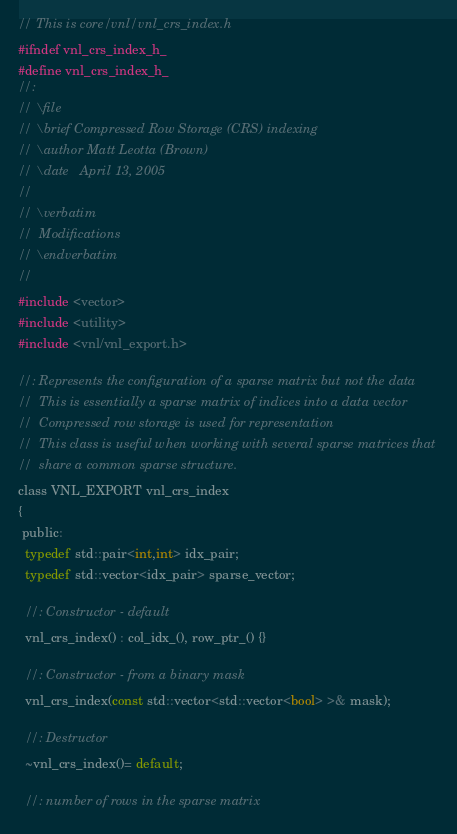<code> <loc_0><loc_0><loc_500><loc_500><_C_>// This is core/vnl/vnl_crs_index.h
#ifndef vnl_crs_index_h_
#define vnl_crs_index_h_
//:
// \file
// \brief Compressed Row Storage (CRS) indexing
// \author Matt Leotta (Brown)
// \date   April 13, 2005
//
// \verbatim
//  Modifications
// \endverbatim
//
#include <vector>
#include <utility>
#include <vnl/vnl_export.h>

//: Represents the configuration of a sparse matrix but not the data
//  This is essentially a sparse matrix of indices into a data vector
//  Compressed row storage is used for representation
//  This class is useful when working with several sparse matrices that
//  share a common sparse structure.
class VNL_EXPORT vnl_crs_index
{
 public:
  typedef std::pair<int,int> idx_pair;
  typedef std::vector<idx_pair> sparse_vector;

  //: Constructor - default
  vnl_crs_index() : col_idx_(), row_ptr_() {}

  //: Constructor - from a binary mask
  vnl_crs_index(const std::vector<std::vector<bool> >& mask);

  //: Destructor
  ~vnl_crs_index()= default;

  //: number of rows in the sparse matrix</code> 